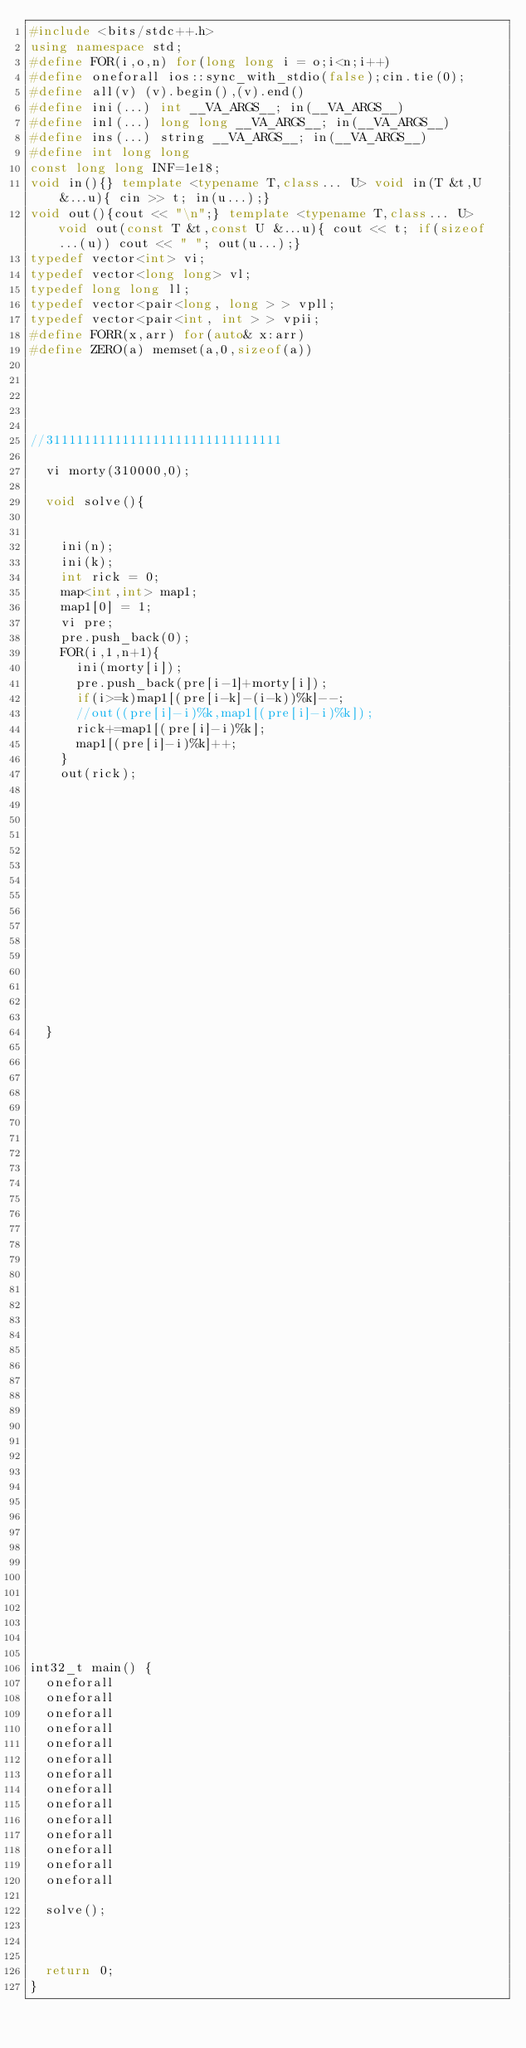<code> <loc_0><loc_0><loc_500><loc_500><_C++_>#include <bits/stdc++.h>
using namespace std;
#define FOR(i,o,n) for(long long i = o;i<n;i++)
#define oneforall ios::sync_with_stdio(false);cin.tie(0);
#define all(v) (v).begin(),(v).end()
#define ini(...) int __VA_ARGS__; in(__VA_ARGS__)
#define inl(...) long long __VA_ARGS__; in(__VA_ARGS__)
#define ins(...) string __VA_ARGS__; in(__VA_ARGS__)
#define int long long 
const long long INF=1e18;
void in(){} template <typename T,class... U> void in(T &t,U &...u){ cin >> t; in(u...);}
void out(){cout << "\n";} template <typename T,class... U> void out(const T &t,const U &...u){ cout << t; if(sizeof...(u)) cout << " "; out(u...);}
typedef vector<int> vi;
typedef vector<long long> vl;
typedef long long ll;
typedef vector<pair<long, long > > vpll;
typedef vector<pair<int, int > > vpii;
#define FORR(x,arr) for(auto& x:arr)
#define ZERO(a) memset(a,0,sizeof(a))





//3111111111111111111111111111111

	vi morty(310000,0);

	void solve(){

		
		ini(n);
		ini(k);
		int rick = 0;
		map<int,int> map1;
		map1[0] = 1;
		vi pre;
		pre.push_back(0);
		FOR(i,1,n+1){
			ini(morty[i]);
			pre.push_back(pre[i-1]+morty[i]);
			if(i>=k)map1[(pre[i-k]-(i-k))%k]--;
			//out((pre[i]-i)%k,map1[(pre[i]-i)%k]);
			rick+=map1[(pre[i]-i)%k];
			map1[(pre[i]-i)%k]++;
		}
		out(rick);
















	}









































int32_t main() {
	oneforall
	oneforall
	oneforall
	oneforall
	oneforall
	oneforall
	oneforall
	oneforall
	oneforall
	oneforall
	oneforall
	oneforall
	oneforall 
	oneforall

	solve();
	


	return 0;
}</code> 